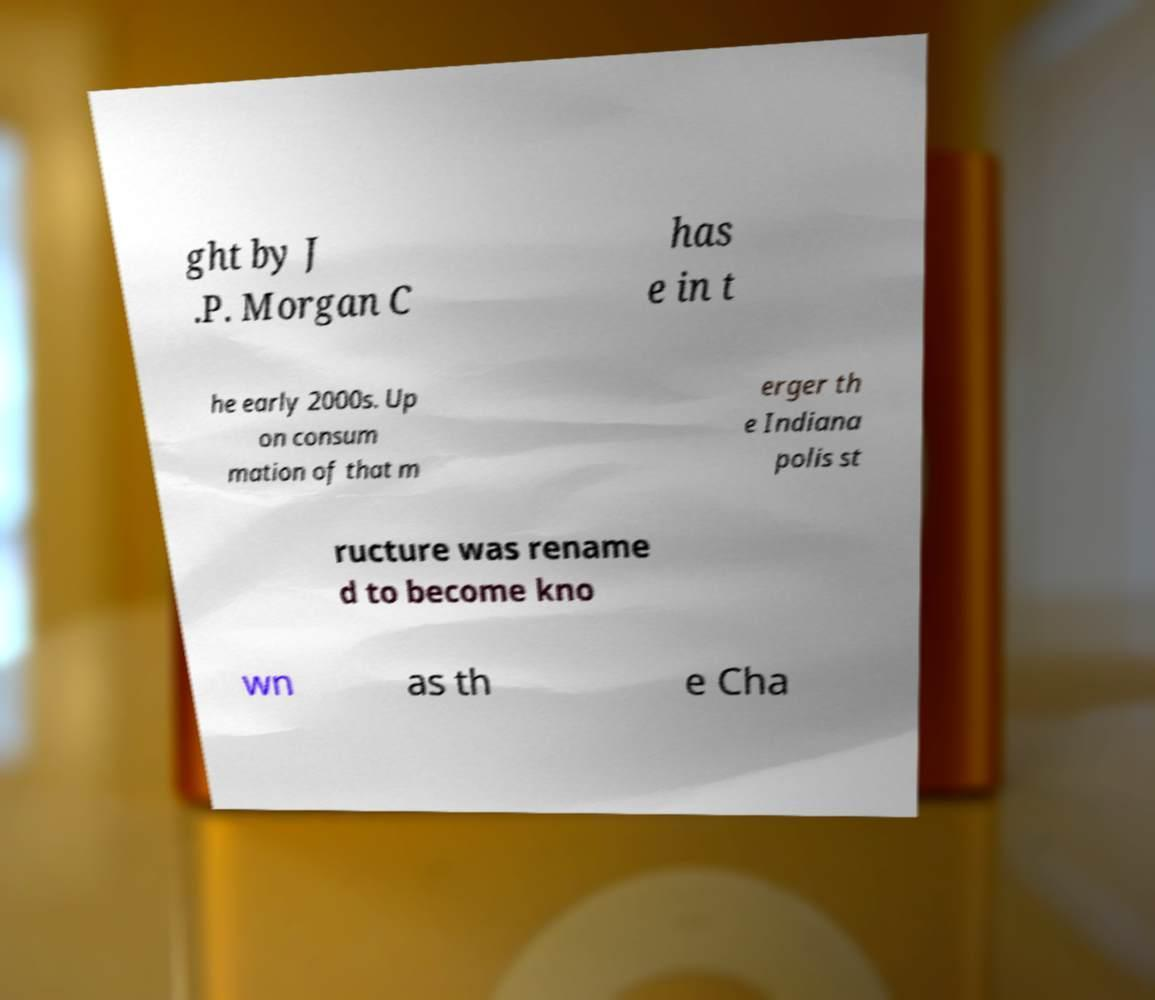What messages or text are displayed in this image? I need them in a readable, typed format. ght by J .P. Morgan C has e in t he early 2000s. Up on consum mation of that m erger th e Indiana polis st ructure was rename d to become kno wn as th e Cha 